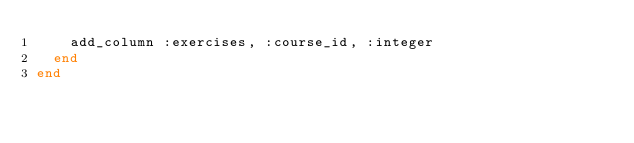Convert code to text. <code><loc_0><loc_0><loc_500><loc_500><_Ruby_>    add_column :exercises, :course_id, :integer
  end
end
</code> 